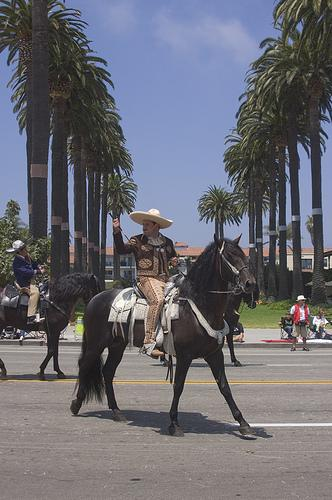What type of hat is the man wearing? Please explain your reasoning. sombrero. A man is wearing a hat with a large brim around it. 